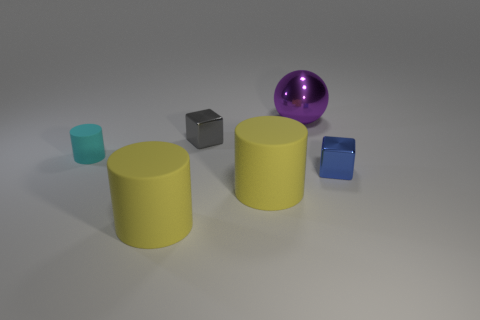Is the material of the thing that is to the right of the purple metal object the same as the cyan cylinder?
Ensure brevity in your answer.  No. There is another small object that is the same shape as the blue metal thing; what color is it?
Your response must be concise. Gray. What number of other objects are the same color as the shiny ball?
Your answer should be compact. 0. Do the thing that is right of the big shiny sphere and the small shiny thing that is on the left side of the purple metallic sphere have the same shape?
Ensure brevity in your answer.  Yes. What number of spheres are cyan things or metal objects?
Make the answer very short. 1. Is the number of small metal things that are to the left of the large shiny thing less than the number of large blue metal objects?
Give a very brief answer. No. How many other objects are the same material as the large ball?
Your answer should be compact. 2. Do the sphere and the cyan cylinder have the same size?
Your answer should be very brief. No. How many objects are either tiny metal objects that are behind the tiny cyan rubber cylinder or metal cubes?
Provide a short and direct response. 2. What material is the cylinder right of the small metal cube to the left of the tiny blue block made of?
Keep it short and to the point. Rubber. 